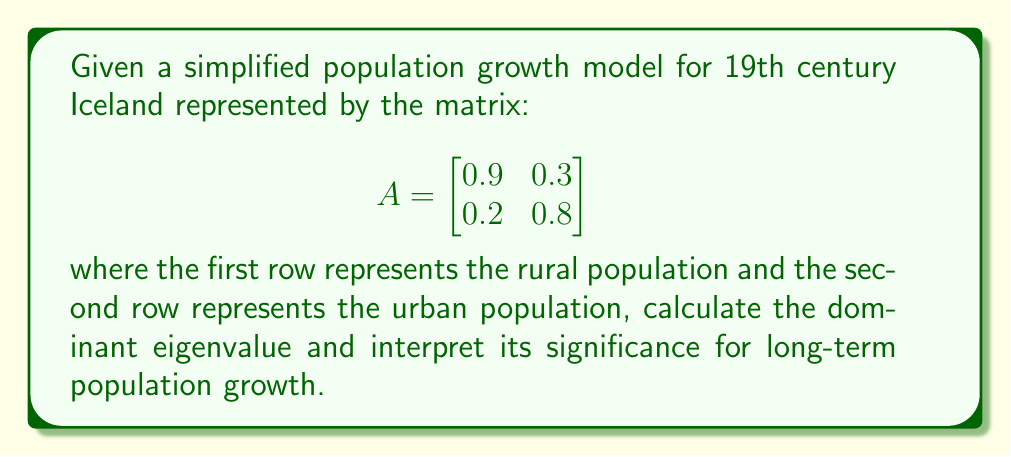Provide a solution to this math problem. 1) To find the eigenvalues, we need to solve the characteristic equation:
   $$\det(A - \lambda I) = 0$$

2) Expanding this:
   $$\begin{vmatrix}
   0.9 - \lambda & 0.3 \\
   0.2 & 0.8 - \lambda
   \end{vmatrix} = 0$$

3) Calculating the determinant:
   $$(0.9 - \lambda)(0.8 - \lambda) - 0.3 \cdot 0.2 = 0$$
   $$0.72 - 1.7\lambda + \lambda^2 - 0.06 = 0$$
   $$\lambda^2 - 1.7\lambda + 0.66 = 0$$

4) Using the quadratic formula:
   $$\lambda = \frac{1.7 \pm \sqrt{1.7^2 - 4(1)(0.66)}}{2(1)}$$
   $$\lambda = \frac{1.7 \pm \sqrt{2.89 - 2.64}}{2}$$
   $$\lambda = \frac{1.7 \pm \sqrt{0.25}}{2}$$
   $$\lambda = \frac{1.7 \pm 0.5}{2}$$

5) This gives us two eigenvalues:
   $$\lambda_1 = \frac{1.7 + 0.5}{2} = 1.1$$
   $$\lambda_2 = \frac{1.7 - 0.5}{2} = 0.6$$

6) The dominant eigenvalue is the larger one: 1.1

7) Interpretation: The dominant eigenvalue being greater than 1 indicates long-term exponential growth. Specifically, the population is expected to grow by approximately 10% (1.1 times) in each time step over the long run.
Answer: 1.1; indicates 10% growth per time step 